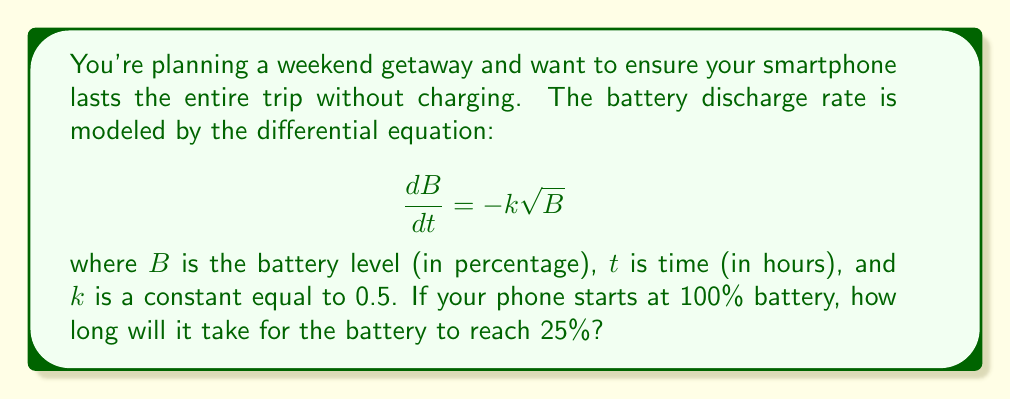Show me your answer to this math problem. Let's solve this problem step-by-step:

1) We start with the differential equation:
   $$\frac{dB}{dt} = -k\sqrt{B}$$

2) Separate variables:
   $$\frac{dB}{\sqrt{B}} = -k dt$$

3) Integrate both sides:
   $$\int \frac{dB}{\sqrt{B}} = -k \int dt$$

4) Solve the integrals:
   $$2\sqrt{B} = -kt + C$$

5) At $t=0$, $B=100$, so we can find $C$:
   $$2\sqrt{100} = C$$
   $$C = 20$$

6) Our solution is now:
   $$2\sqrt{B} = -kt + 20$$

7) We want to find $t$ when $B=25$. Substitute these values:
   $$2\sqrt{25} = -k(t) + 20$$
   $$10 = -0.5t + 20$$

8) Solve for $t$:
   $$-0.5t = -10$$
   $$t = 20$$

Therefore, it will take 20 hours for the battery to reach 25%.
Answer: 20 hours 